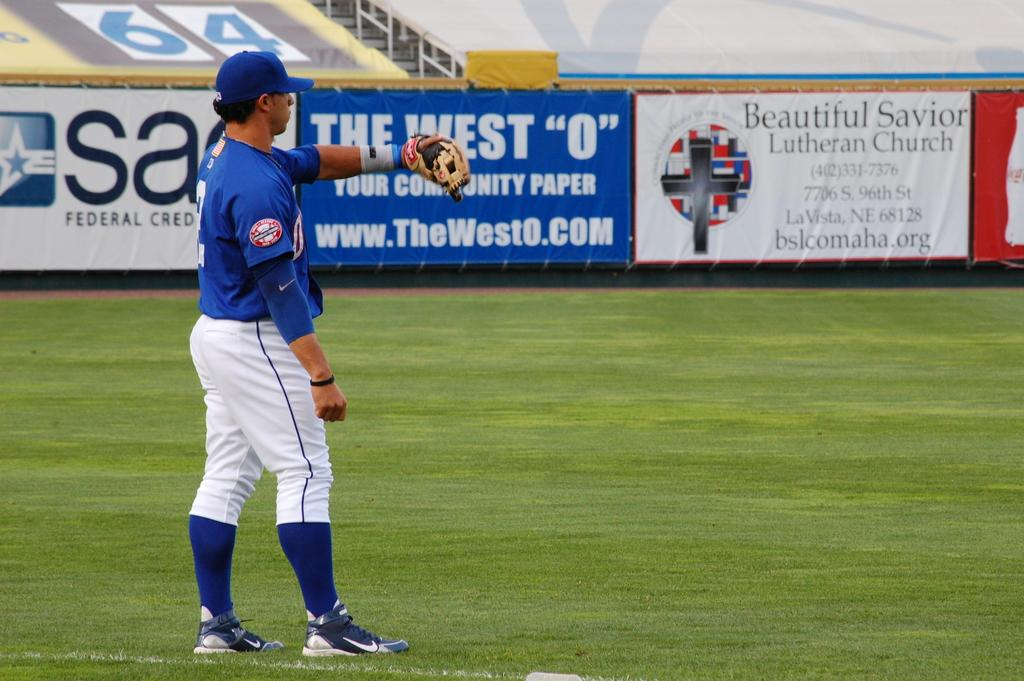Provide a one-sentence caption for the provided image. a baseball player on a field with banners for a lutheren church of fence. 